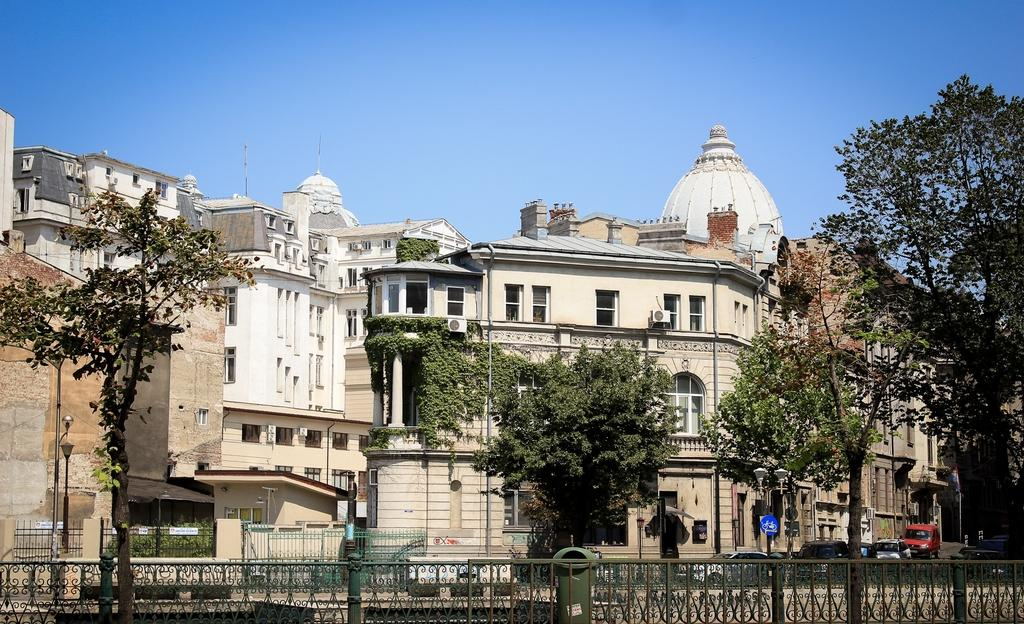What type of structures can be seen in the background of the image? There are buildings in the background of the image. What is located in front of the buildings? Trees are present in front of the buildings. What type of transportation is visible on the road? Vehicles are visible on the road. What is visible above the scene? The sky is visible above the scene. Can you see any stamps on the vehicles in the image? There are no stamps visible on the vehicles in the image. Are there any planes flying in the sky above the scene? There is no mention of planes in the image, only the sky is visible. How does the wind affect the trees in the image? The provided facts do not mention the wind, so we cannot determine its effect on the trees in the image. 